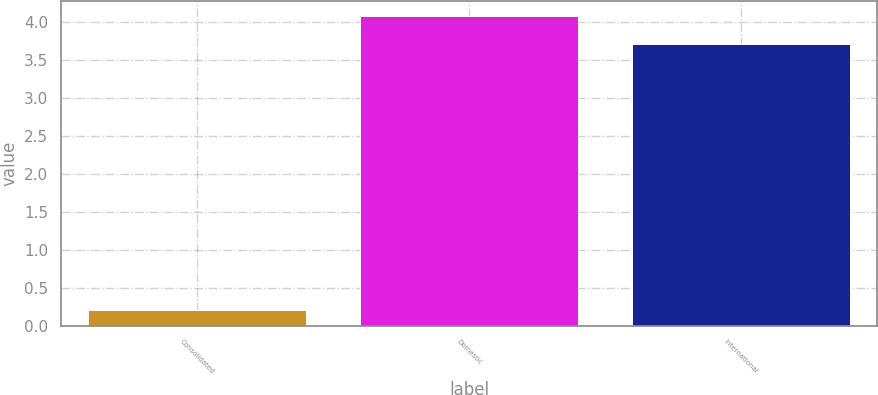Convert chart. <chart><loc_0><loc_0><loc_500><loc_500><bar_chart><fcel>Consolidated<fcel>Domestic<fcel>International<nl><fcel>0.2<fcel>4.07<fcel>3.7<nl></chart> 